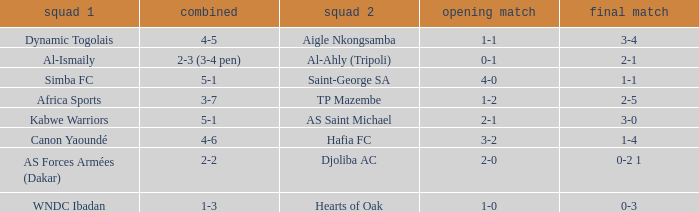What team played against Al-Ismaily (team 1)? Al-Ahly (Tripoli). 